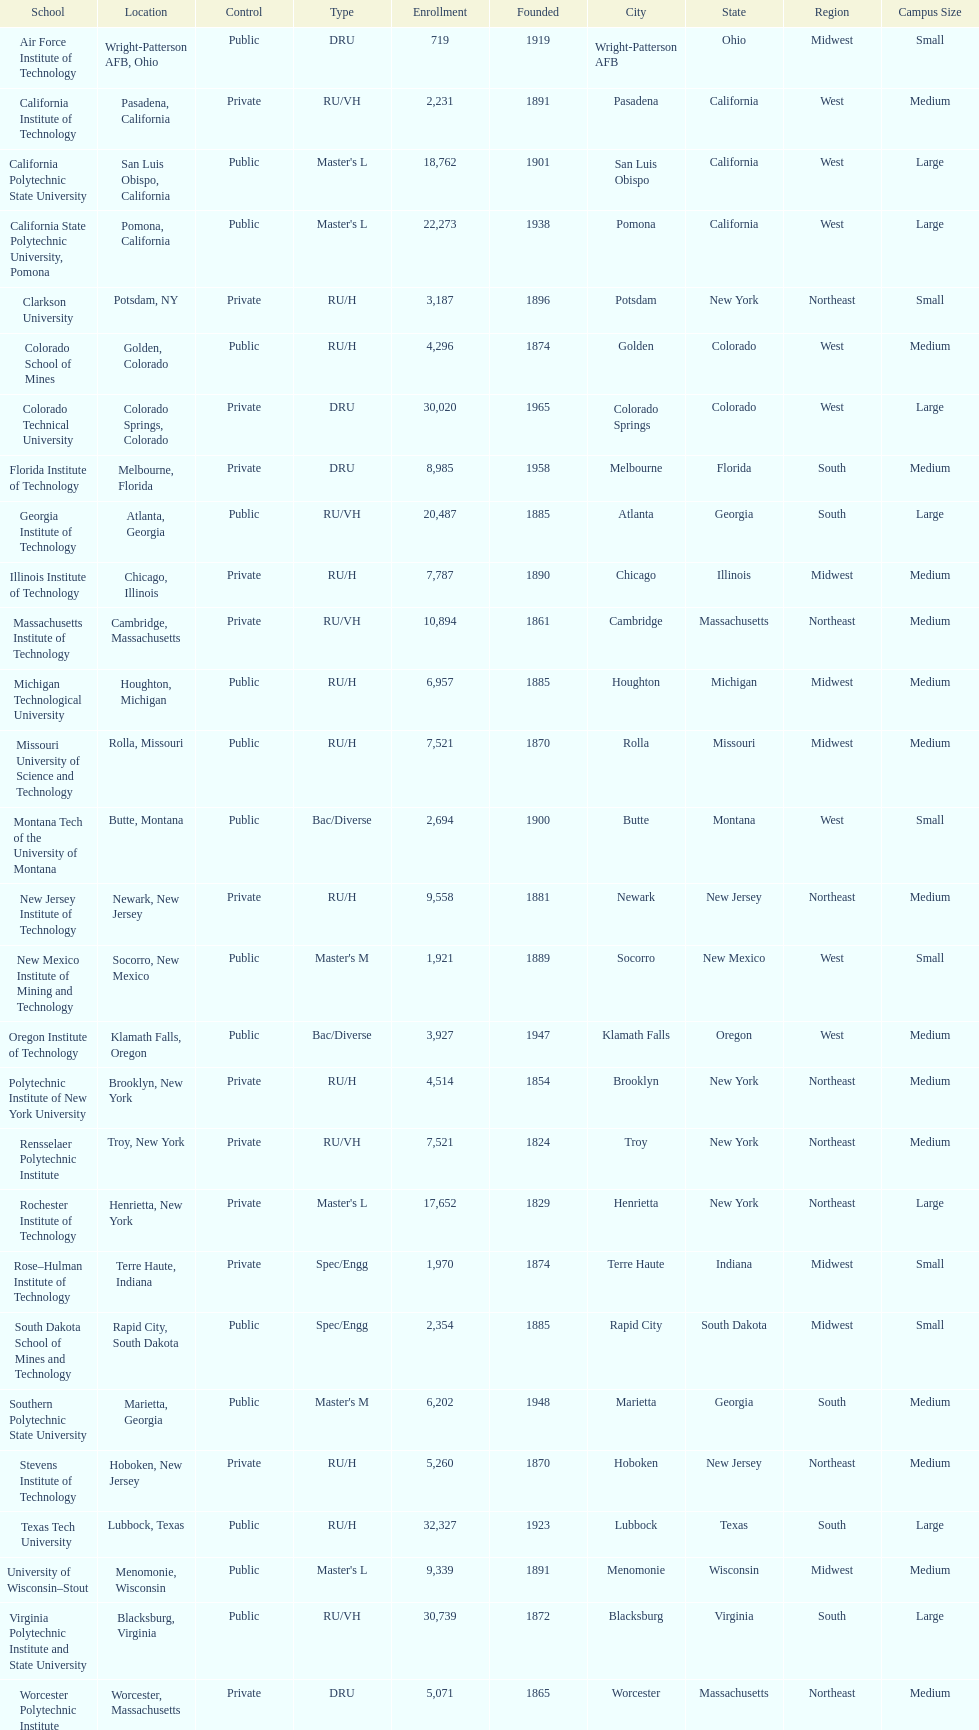Which school had the largest enrollment? Texas Tech University. 